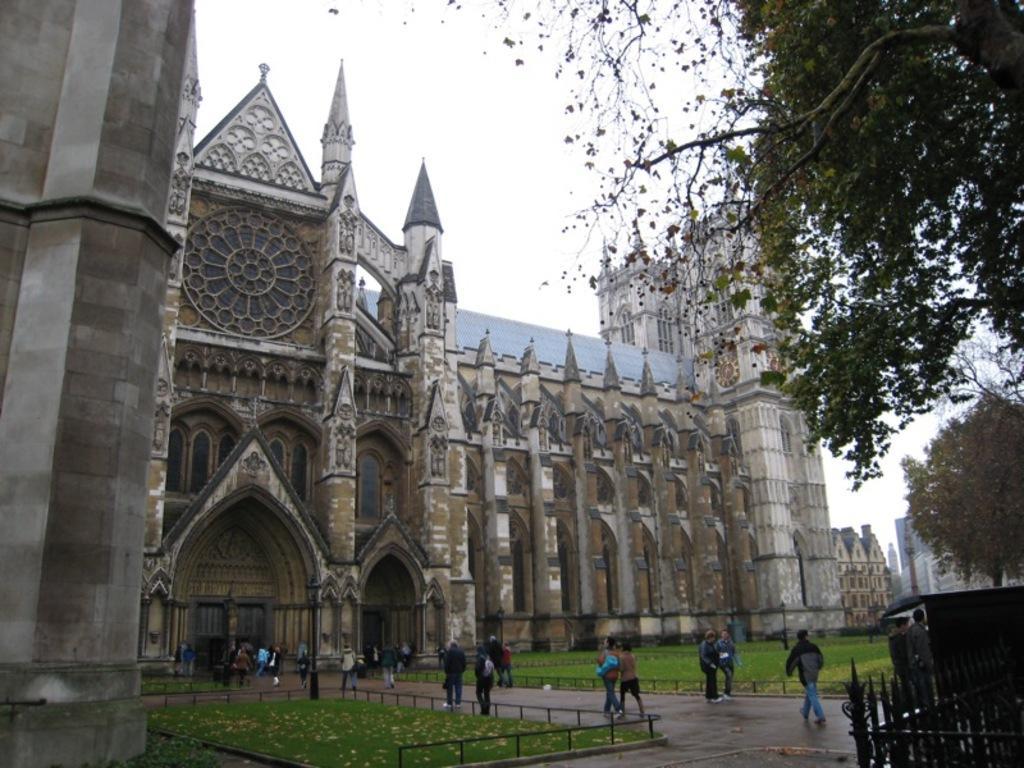Can you describe this image briefly? In this picture i can see the church, buildings and trees. At the bottom there is a man who is wearing jacket, jeans and shoe. He is walking on the road, beside him there is a man who is standing near to the shed and fencing. Beside the street light i can see many people were walking. At the top there is a sky. In the bottom left i can see the grass and leaves. 